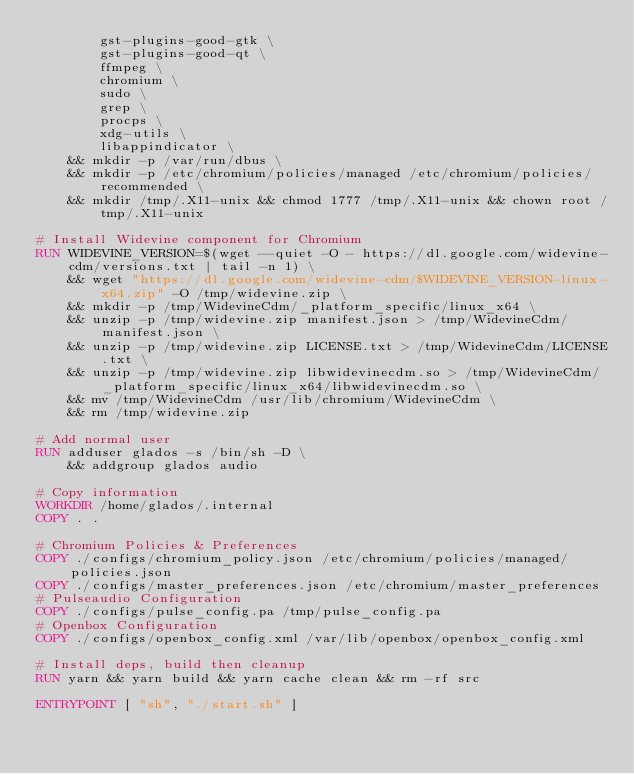<code> <loc_0><loc_0><loc_500><loc_500><_Dockerfile_>        gst-plugins-good-gtk \
        gst-plugins-good-qt \
        ffmpeg \
        chromium \
        sudo \
        grep \
        procps \
        xdg-utils \
        libappindicator \
    && mkdir -p /var/run/dbus \
    && mkdir -p /etc/chromium/policies/managed /etc/chromium/policies/recommended \
    && mkdir /tmp/.X11-unix && chmod 1777 /tmp/.X11-unix && chown root /tmp/.X11-unix
    
# Install Widevine component for Chromium
RUN WIDEVINE_VERSION=$(wget --quiet -O - https://dl.google.com/widevine-cdm/versions.txt | tail -n 1) \
    && wget "https://dl.google.com/widevine-cdm/$WIDEVINE_VERSION-linux-x64.zip" -O /tmp/widevine.zip \
    && mkdir -p /tmp/WidevineCdm/_platform_specific/linux_x64 \
    && unzip -p /tmp/widevine.zip manifest.json > /tmp/WidevineCdm/manifest.json \
    && unzip -p /tmp/widevine.zip LICENSE.txt > /tmp/WidevineCdm/LICENSE.txt \
    && unzip -p /tmp/widevine.zip libwidevinecdm.so > /tmp/WidevineCdm/_platform_specific/linux_x64/libwidevinecdm.so \
    && mv /tmp/WidevineCdm /usr/lib/chromium/WidevineCdm \
    && rm /tmp/widevine.zip

# Add normal user
RUN adduser glados -s /bin/sh -D \
    && addgroup glados audio

# Copy information
WORKDIR /home/glados/.internal
COPY . .

# Chromium Policies & Preferences
COPY ./configs/chromium_policy.json /etc/chromium/policies/managed/policies.json
COPY ./configs/master_preferences.json /etc/chromium/master_preferences
# Pulseaudio Configuration
COPY ./configs/pulse_config.pa /tmp/pulse_config.pa
# Openbox Configuration
COPY ./configs/openbox_config.xml /var/lib/openbox/openbox_config.xml

# Install deps, build then cleanup
RUN yarn && yarn build && yarn cache clean && rm -rf src

ENTRYPOINT [ "sh", "./start.sh" ]
</code> 